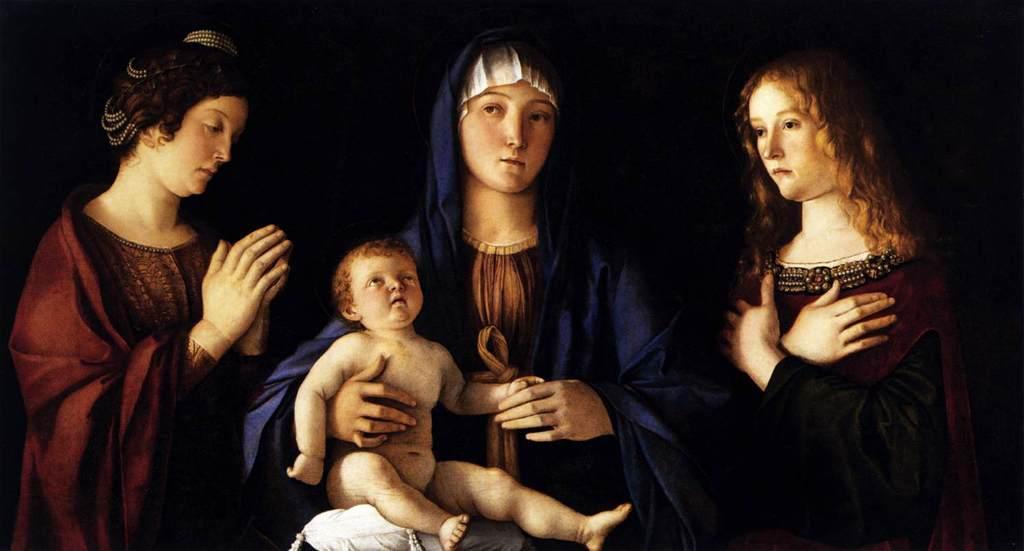Please provide a concise description of this image. In this image I can see depiction of three women and of a baby. I can also see black colour in background and on the bottom side of this image I can see a white colour cushion. 